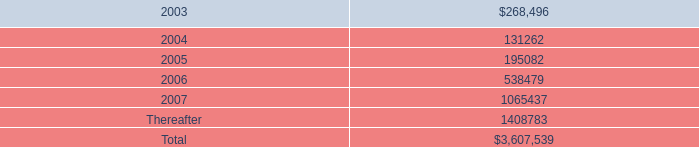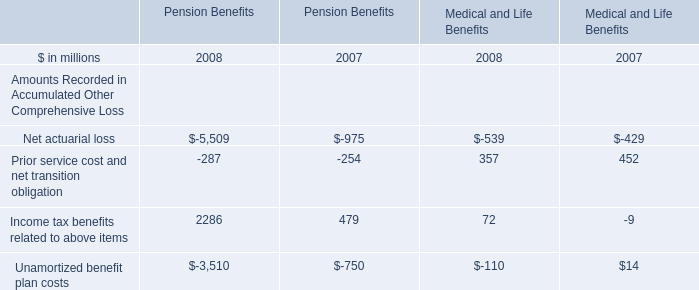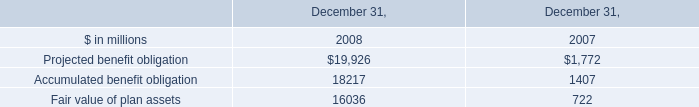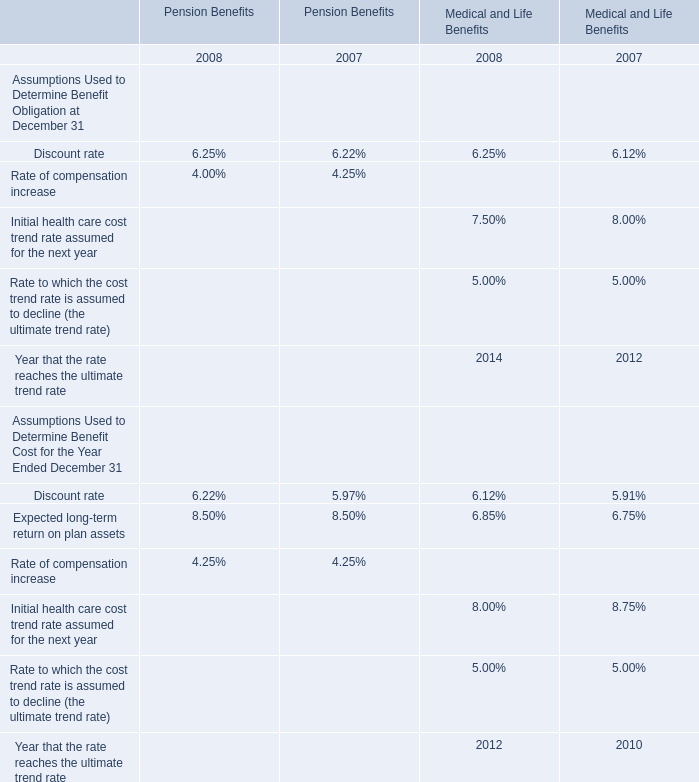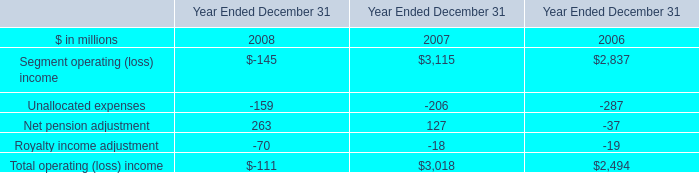What was the average of the Accumulated benefit obligation in the years where Projected benefit obligation is positive? (in million) 
Computations: ((18217 + 1407) / 2)
Answer: 9812.0. 